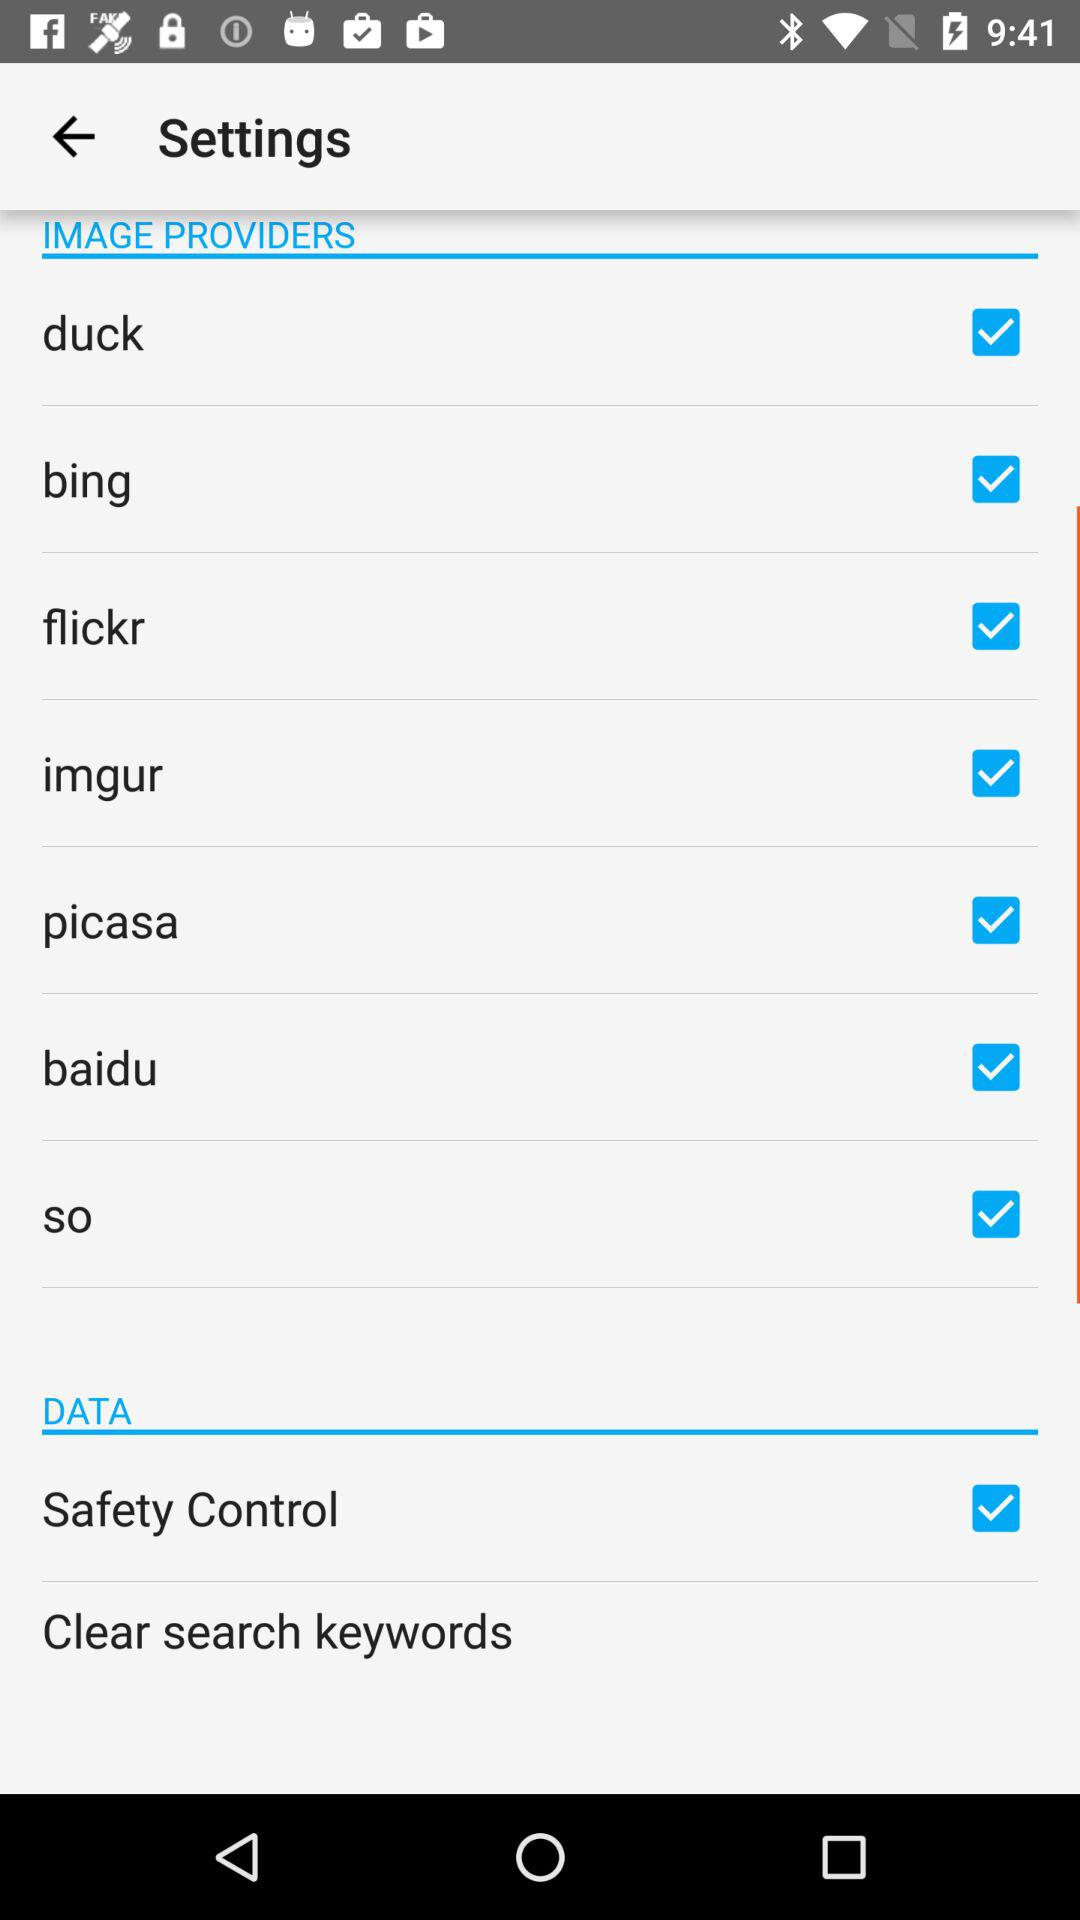What's the status of "Safety Control"? The status of "Safety Control" is "on". 